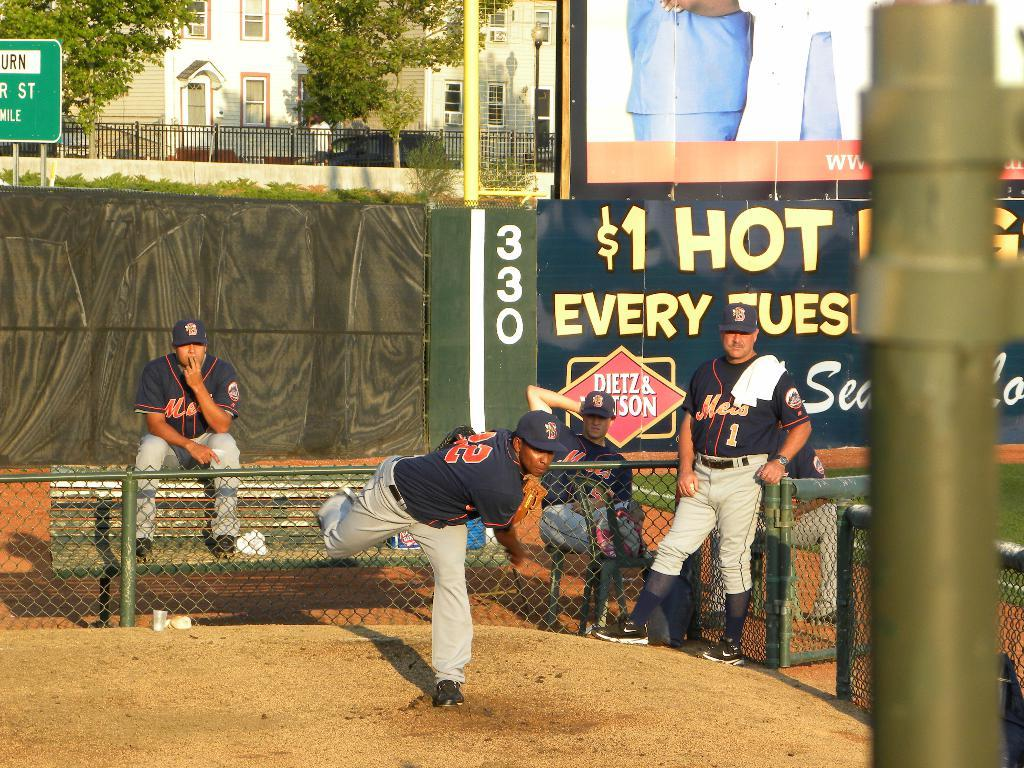<image>
Render a clear and concise summary of the photo. Hot dogs can be bought for $1 at this baseball game. 